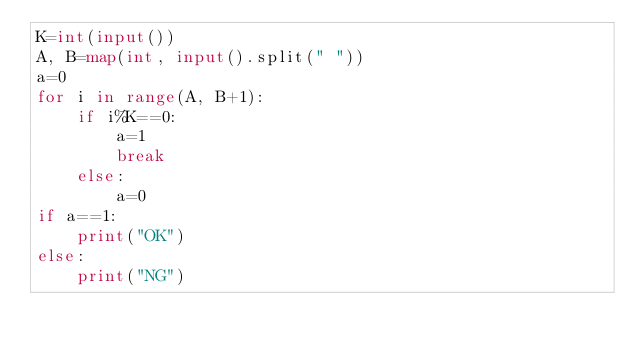<code> <loc_0><loc_0><loc_500><loc_500><_Python_>K=int(input())
A, B=map(int, input().split(" "))
a=0
for i in range(A, B+1):
    if i%K==0:
        a=1
        break
    else:
        a=0
if a==1:
    print("OK")
else:
    print("NG")</code> 